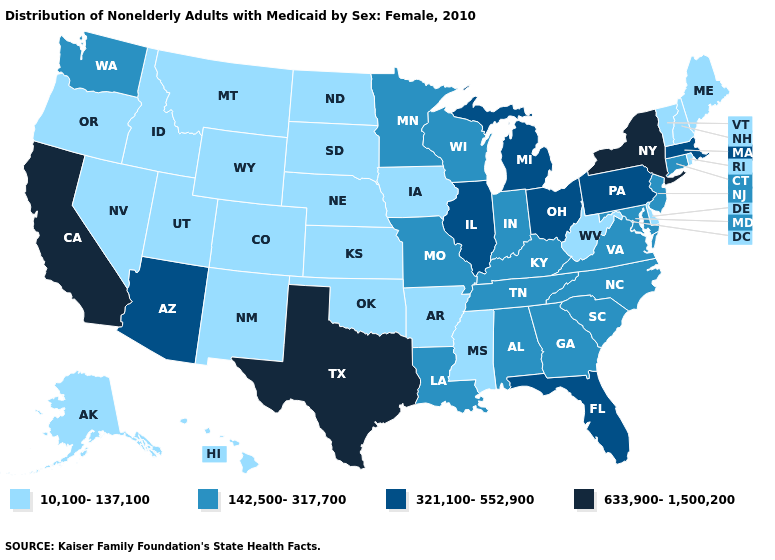What is the value of Idaho?
Keep it brief. 10,100-137,100. What is the value of Rhode Island?
Quick response, please. 10,100-137,100. Which states have the lowest value in the USA?
Concise answer only. Alaska, Arkansas, Colorado, Delaware, Hawaii, Idaho, Iowa, Kansas, Maine, Mississippi, Montana, Nebraska, Nevada, New Hampshire, New Mexico, North Dakota, Oklahoma, Oregon, Rhode Island, South Dakota, Utah, Vermont, West Virginia, Wyoming. Name the states that have a value in the range 321,100-552,900?
Write a very short answer. Arizona, Florida, Illinois, Massachusetts, Michigan, Ohio, Pennsylvania. Name the states that have a value in the range 321,100-552,900?
Be succinct. Arizona, Florida, Illinois, Massachusetts, Michigan, Ohio, Pennsylvania. What is the highest value in the MidWest ?
Short answer required. 321,100-552,900. Does Pennsylvania have a higher value than Maine?
Give a very brief answer. Yes. Does Vermont have the same value as Arkansas?
Be succinct. Yes. Among the states that border Mississippi , which have the lowest value?
Give a very brief answer. Arkansas. What is the value of North Carolina?
Quick response, please. 142,500-317,700. Name the states that have a value in the range 142,500-317,700?
Quick response, please. Alabama, Connecticut, Georgia, Indiana, Kentucky, Louisiana, Maryland, Minnesota, Missouri, New Jersey, North Carolina, South Carolina, Tennessee, Virginia, Washington, Wisconsin. Does North Dakota have the highest value in the USA?
Answer briefly. No. What is the lowest value in the USA?
Concise answer only. 10,100-137,100. Among the states that border Illinois , does Iowa have the highest value?
Write a very short answer. No. What is the lowest value in the Northeast?
Answer briefly. 10,100-137,100. 